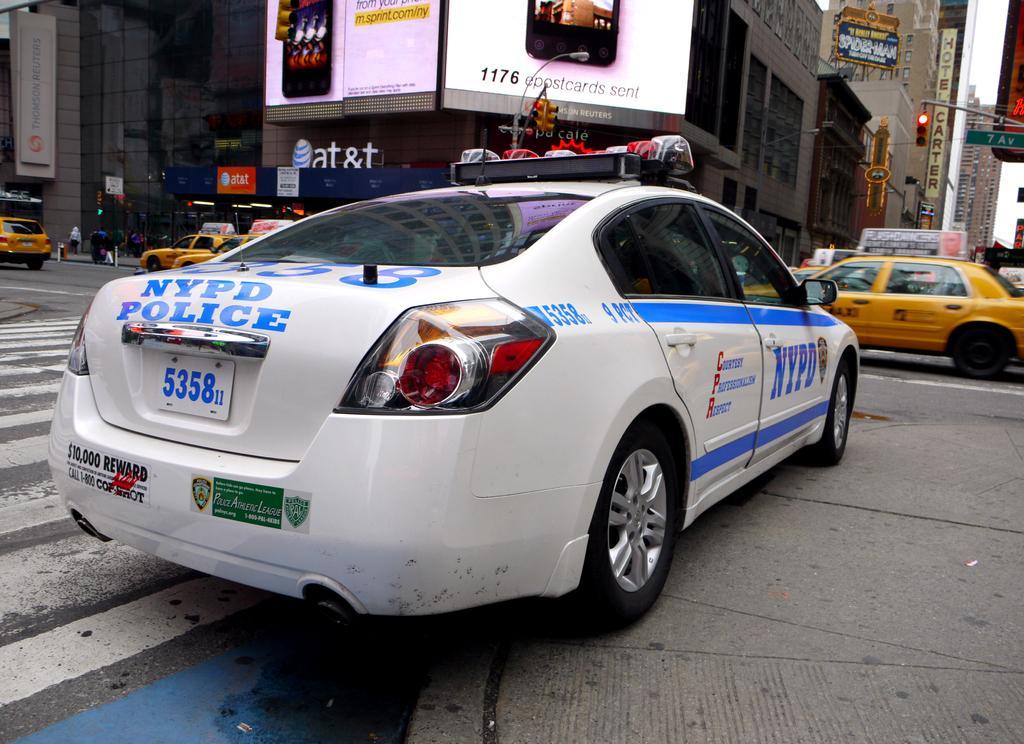Please provide a concise description of this image. In the image there are cars going on the road and behind there are many buildings with ad banners on it. 